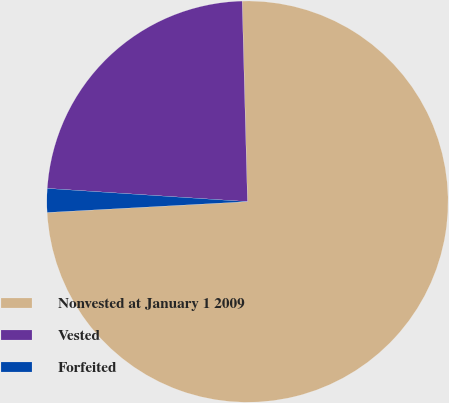Convert chart to OTSL. <chart><loc_0><loc_0><loc_500><loc_500><pie_chart><fcel>Nonvested at January 1 2009<fcel>Vested<fcel>Forfeited<nl><fcel>74.56%<fcel>23.53%<fcel>1.91%<nl></chart> 